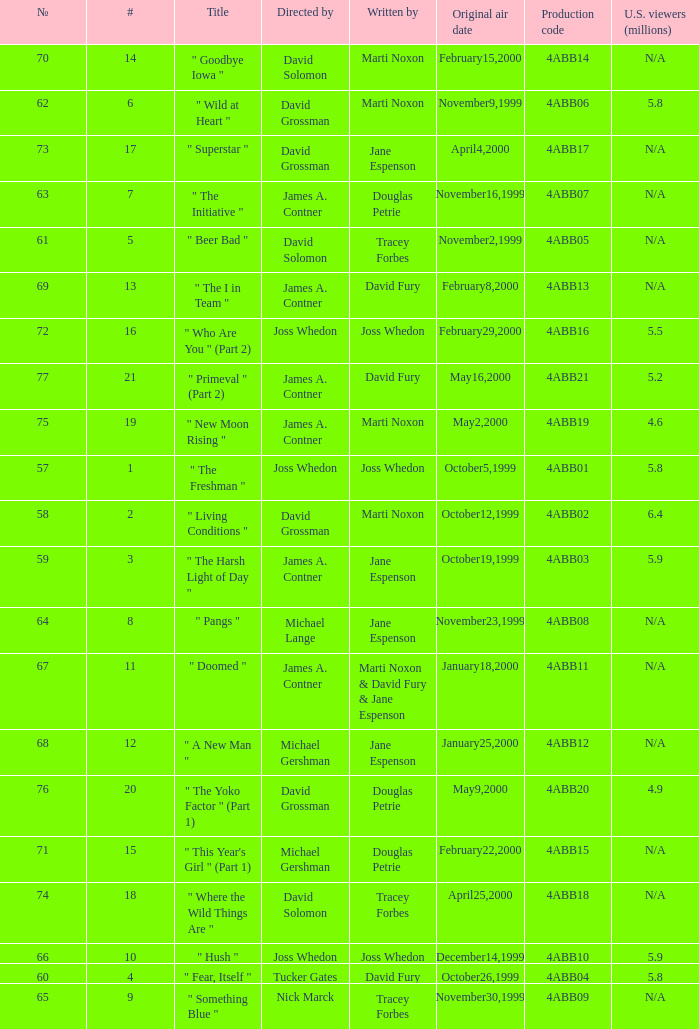What is the season 4 # for the production code of 4abb07? 7.0. 